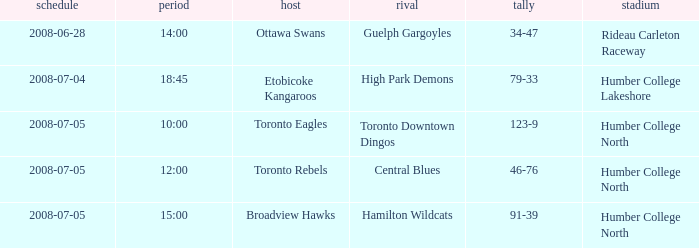What is the Away with a Time that is 14:00? Guelph Gargoyles. 